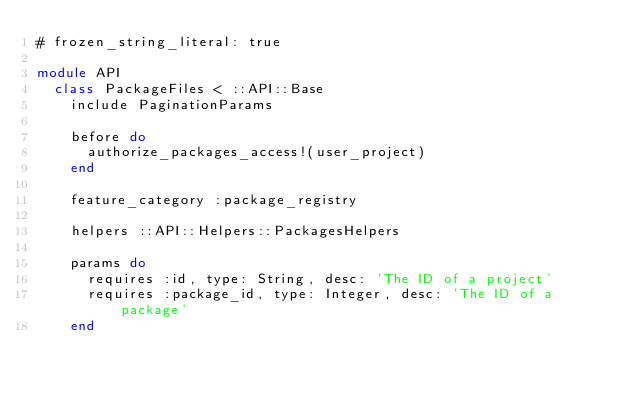<code> <loc_0><loc_0><loc_500><loc_500><_Ruby_># frozen_string_literal: true

module API
  class PackageFiles < ::API::Base
    include PaginationParams

    before do
      authorize_packages_access!(user_project)
    end

    feature_category :package_registry

    helpers ::API::Helpers::PackagesHelpers

    params do
      requires :id, type: String, desc: 'The ID of a project'
      requires :package_id, type: Integer, desc: 'The ID of a package'
    end</code> 